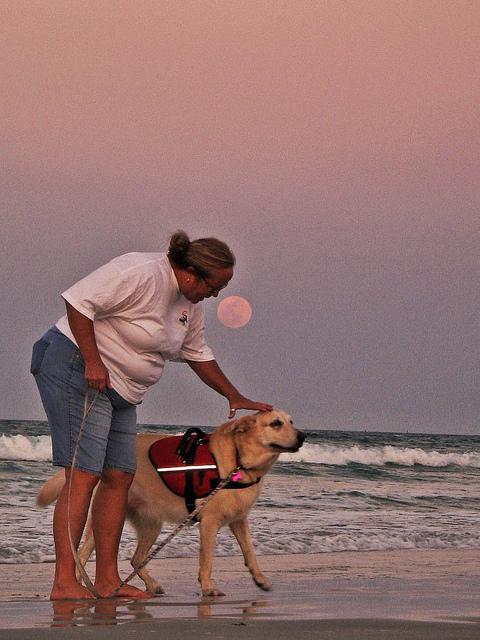Which animal is this?
Short answer required. Dog. Is the moon visible?
Be succinct. Yes. What color is the dog?
Concise answer only. Tan. Would this be a service animal?
Keep it brief. Yes. Is the dog pleased?
Concise answer only. Yes. What is in front of the woman's face?
Short answer required. Moon. Is the girl in mid-jump?
Answer briefly. No. 